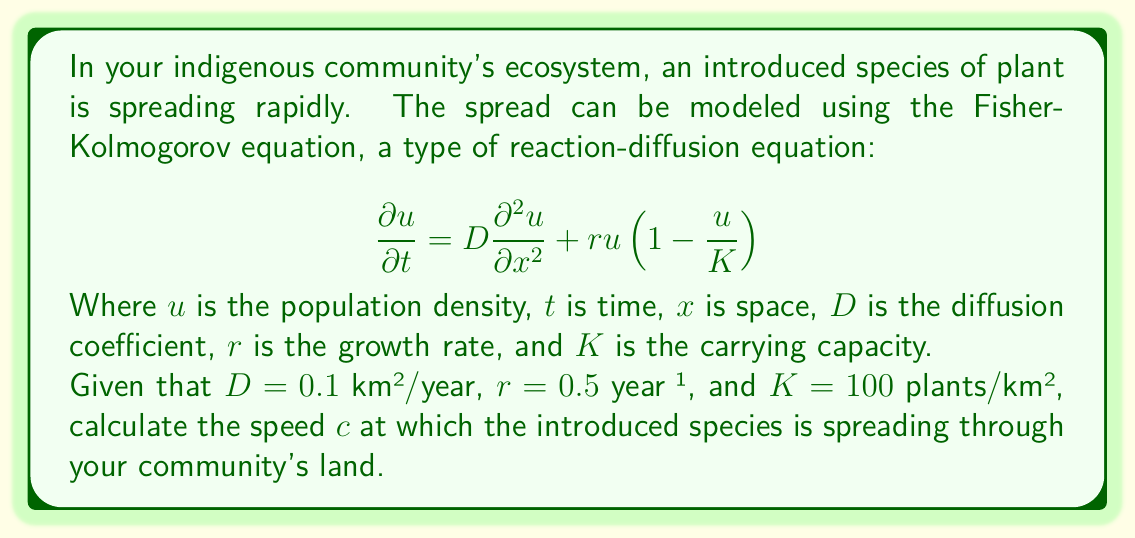Can you solve this math problem? To solve this problem, we'll use the formula for the spreading speed of a population described by the Fisher-Kolmogorov equation:

$$c = 2\sqrt{rD}$$

This formula gives the asymptotic speed of the traveling wave solution to the Fisher-Kolmogorov equation.

Let's substitute the given values:

$r = 0.5$ year⁻¹
$D = 0.1$ km²/year

Now, let's calculate:

$$c = 2\sqrt{0.5 \cdot 0.1}$$

$$c = 2\sqrt{0.05}$$

$$c = 2 \cdot 0.2236$$

$$c = 0.4472$$ km/year

This result represents the speed at which the introduced species is spreading through your community's ecosystem.

It's worth noting that this model assumes a homogeneous environment. In reality, your indigenous community's land likely has varied terrain and microclimates that could affect the spread rate. However, this calculation provides a good baseline estimate for the spread of the introduced species.
Answer: The introduced species is spreading at a speed of approximately 0.4472 km/year. 